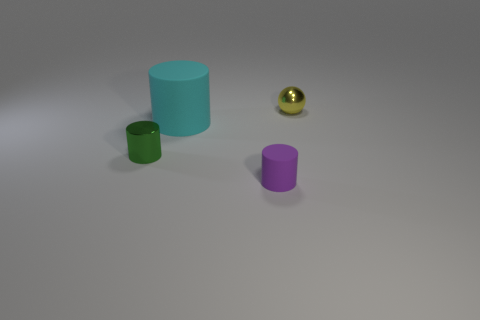How many other things are the same shape as the green metallic thing?
Your response must be concise. 2. How many things are either green rubber blocks or small metal things that are in front of the big cyan matte object?
Your response must be concise. 1. What material is the green object?
Make the answer very short. Metal. There is a cyan object that is the same shape as the purple object; what is its material?
Provide a succinct answer. Rubber. The small shiny object on the left side of the small cylinder in front of the small metallic cylinder is what color?
Your response must be concise. Green. How many shiny objects are brown things or small purple things?
Provide a short and direct response. 0. Does the tiny yellow sphere have the same material as the cyan object?
Give a very brief answer. No. What material is the small object behind the small cylinder that is behind the purple thing?
Your answer should be compact. Metal. What number of large objects are either rubber cylinders or cyan rubber things?
Your answer should be very brief. 1. What size is the sphere?
Your response must be concise. Small. 